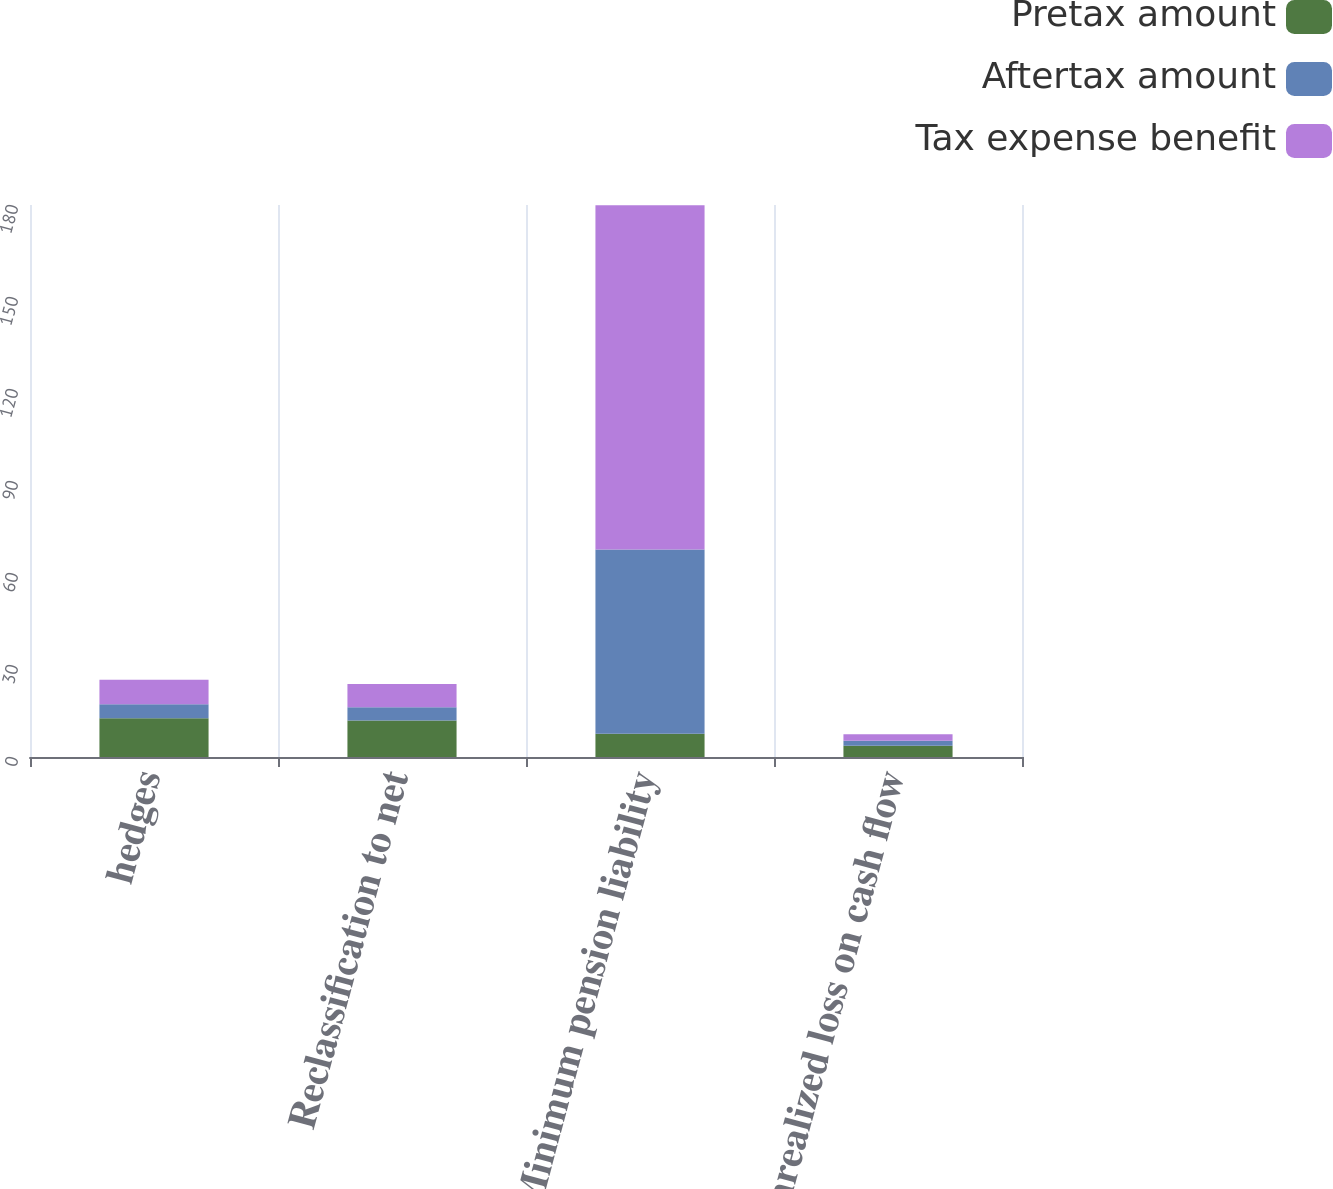Convert chart. <chart><loc_0><loc_0><loc_500><loc_500><stacked_bar_chart><ecel><fcel>hedges<fcel>Reclassification to net<fcel>Minimum pension liability<fcel>Unrealized loss on cash flow<nl><fcel>Pretax amount<fcel>12.6<fcel>11.9<fcel>7.6<fcel>3.7<nl><fcel>Aftertax amount<fcel>4.6<fcel>4.3<fcel>60.1<fcel>1.6<nl><fcel>Tax expense benefit<fcel>8<fcel>7.6<fcel>112.2<fcel>2.1<nl></chart> 